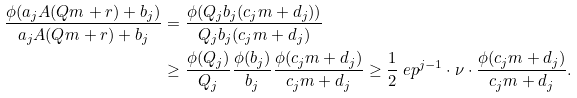Convert formula to latex. <formula><loc_0><loc_0><loc_500><loc_500>\frac { \phi ( a _ { j } A ( Q m + r ) + b _ { j } ) } { a _ { j } A ( Q m + r ) + b _ { j } } & = \frac { \phi ( Q _ { j } b _ { j } ( c _ { j } m + d _ { j } ) ) } { Q _ { j } b _ { j } ( c _ { j } m + d _ { j } ) } \\ & \geq \frac { \phi ( Q _ { j } ) } { Q _ { j } } \frac { \phi ( b _ { j } ) } { b _ { j } } \frac { \phi ( c _ { j } m + d _ { j } ) } { c _ { j } m + d _ { j } } \geq \frac { 1 } { 2 } \ e p ^ { j - 1 } \cdot \nu \cdot \frac { \phi ( c _ { j } m + d _ { j } ) } { c _ { j } m + d _ { j } } .</formula> 